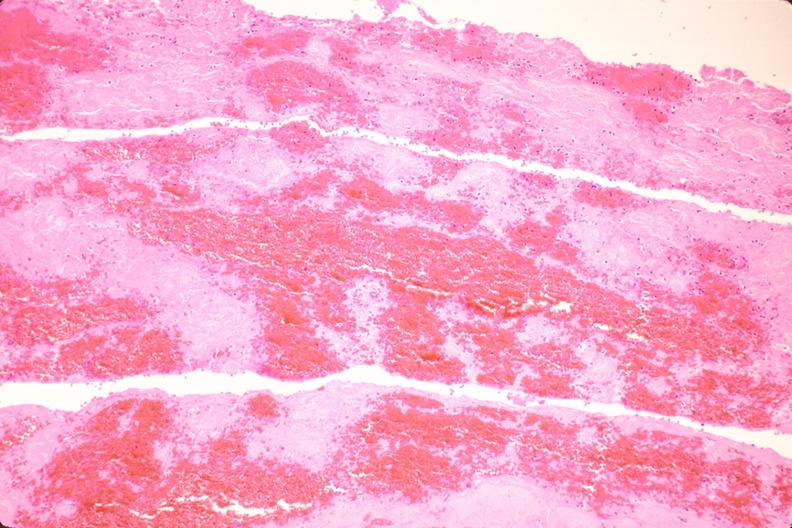s cardiovascular present?
Answer the question using a single word or phrase. Yes 